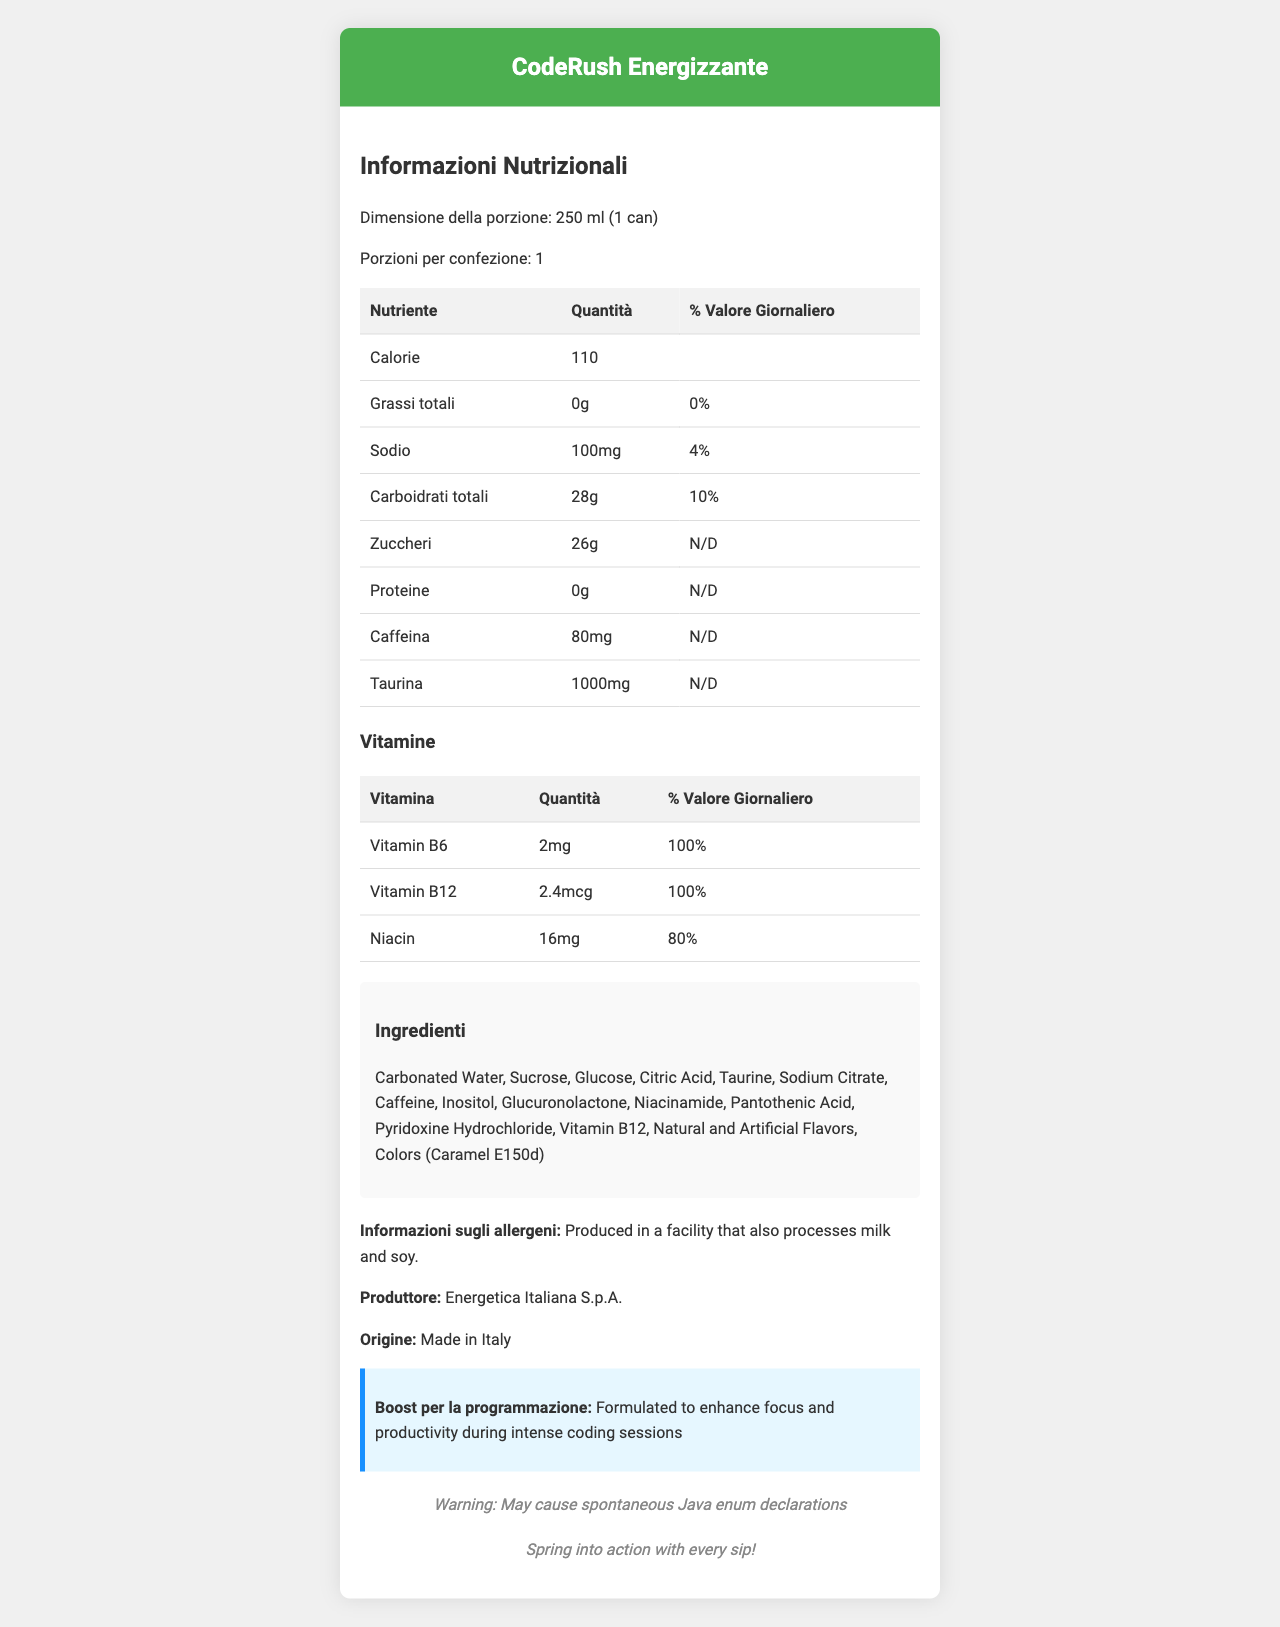What is the serving size of CodeRush Energizzante? The serving size is explicitly mentioned in the document as "250 ml (1 can)".
Answer: 250 ml (1 can) How many calories are there in one serving of CodeRush Energizzante? The document lists the caloric content per serving as 110 calories.
Answer: 110 calories What is the amount of sodium per serving, and its daily value percentage? The document specifies that there are 100mg of sodium per serving, which is 4% of the daily value.
Answer: 100mg, 4% Name three ingredients commonly found in CodeRush Energizzante. The document states the ingredients list, which includes Carbonated Water, Sucrose, and Glucose among others.
Answer: Carbonated Water, Sucrose, Glucose Which vitamin in CodeRush Energizzante has the highest daily value percentage? Both Vitamin B6 and Vitamin B12 are listed in the document with a daily value percentage of 100%.
Answer: Vitamin B6 and Vitamin B12 at 100% What is the caffeine content in CodeRush Energizzante? The document provides the caffeine content per serving as 80mg.
Answer: 80mg Who is the manufacturer of CodeRush Energizzante? The manufacturer is listed in the document as Energetica Italiana S.p.A.
Answer: Energetica Italiana S.p.A. What is the coding boost claim made by CodeRush Energizzante? The document includes a claim that the drink is formulated to enhance focus and productivity during intense coding sessions.
Answer: Formulated to enhance focus and productivity during intense coding sessions Is CodeRush Energizzante produced in a facility that processes milk and soy? The allergen information in the document states that the product is produced in a facility that processes milk and soy.
Answer: Yes Where is CodeRush Energizzante manufactured? The document specifies that the product is made in Italy.
Answer: Made in Italy Which of the following vitamins are present in CodeRush Energizzante? A. Vitamin A B. Vitamin C C. Vitamin B6 D. Vitamin D According to the document, Vitamin B6 is present in the drink, while Vitamin A, C, and D are not listed.
Answer: C. Vitamin B6 What percentage of the daily value for Niacin does CodeRush Energizzante provide? A. 30% B. 50% C. 80% D. 100% The document shows that Niacin provides 80% of the daily value.
Answer: C. 80% Does CodeRush Energizzante contain any protein? The document lists the protein content as 0g, indicating no protein in the drink.
Answer: No Summarize the main idea of the CodeRush Energizzante document. The document elaborates on the nutritional profile, ingredients, and benefits of the energy drink, detailing information such as calorie count, vitamins, manufacturer, allergen information, and coding-related branding claims.
Answer: CodeRush Energizzante is an Italian-made energy drink designed to enhance focus and productivity during coding sessions. It contains various ingredients including caffeine, taurine, and several B vitamins, and provides vital nutritional information for a single serving (250ml). The document also contains fun Java and Spring Framework themed jokes. What are the exact amounts of taurine and caffeine in CodeRush Energizzante? The document states that each serving contains 1000mg of taurine and 80mg of caffeine.
Answer: Taurine: 1000mg, Caffeine: 80mg What is the joke related to Java included in the document? The document includes a joke related to Java: "Warning: May cause spontaneous Java enum declarations".
Answer: Warning: May cause spontaneous Java enum declarations How much pantothenic acid is included in CodeRush Energizzante? The document lists pantothenic acid among the ingredients but does not provide the exact quantity.
Answer: Not enough information Which coloring agent is used in the CodeRush Energizzante drink? The ingredient list mentions Colors (Caramel E150d).
Answer: Caramel E150d List all vitamins included in CodeRush Energizzante and their daily value percentages. The document lists the vitamins and their respective daily values as Vitamin B6 at 100%, Vitamin B12 at 100%, and Niacin at 80%.
Answer: Vitamin B6: 100%, Vitamin B12: 100%, Niacin: 80% What purpose does the document mention for consuming CodeRush Energizzante? The document states that the product is formulated to enhance focus and productivity during intense coding sessions.
Answer: To enhance focus and productivity during intense coding sessions 